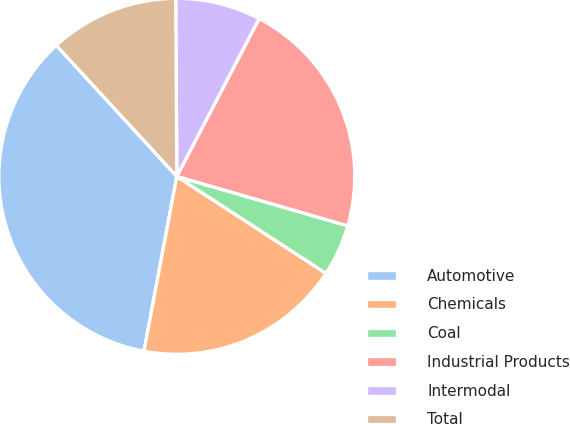Convert chart. <chart><loc_0><loc_0><loc_500><loc_500><pie_chart><fcel>Automotive<fcel>Chemicals<fcel>Coal<fcel>Industrial Products<fcel>Intermodal<fcel>Total<nl><fcel>35.21%<fcel>18.78%<fcel>4.69%<fcel>21.83%<fcel>7.75%<fcel>11.74%<nl></chart> 